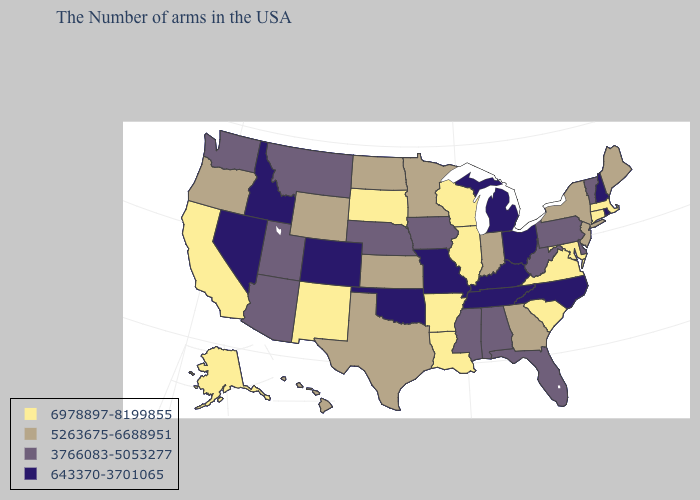Name the states that have a value in the range 643370-3701065?
Be succinct. Rhode Island, New Hampshire, North Carolina, Ohio, Michigan, Kentucky, Tennessee, Missouri, Oklahoma, Colorado, Idaho, Nevada. Name the states that have a value in the range 6978897-8199855?
Concise answer only. Massachusetts, Connecticut, Maryland, Virginia, South Carolina, Wisconsin, Illinois, Louisiana, Arkansas, South Dakota, New Mexico, California, Alaska. What is the value of Indiana?
Give a very brief answer. 5263675-6688951. Which states have the highest value in the USA?
Give a very brief answer. Massachusetts, Connecticut, Maryland, Virginia, South Carolina, Wisconsin, Illinois, Louisiana, Arkansas, South Dakota, New Mexico, California, Alaska. Name the states that have a value in the range 643370-3701065?
Give a very brief answer. Rhode Island, New Hampshire, North Carolina, Ohio, Michigan, Kentucky, Tennessee, Missouri, Oklahoma, Colorado, Idaho, Nevada. Does Nebraska have the highest value in the USA?
Quick response, please. No. What is the value of Nebraska?
Short answer required. 3766083-5053277. Among the states that border Delaware , does New Jersey have the highest value?
Keep it brief. No. What is the value of Kentucky?
Write a very short answer. 643370-3701065. Does Utah have a lower value than Massachusetts?
Keep it brief. Yes. What is the lowest value in states that border Vermont?
Give a very brief answer. 643370-3701065. What is the value of Arizona?
Answer briefly. 3766083-5053277. What is the highest value in the West ?
Write a very short answer. 6978897-8199855. What is the value of New Mexico?
Keep it brief. 6978897-8199855. Name the states that have a value in the range 643370-3701065?
Answer briefly. Rhode Island, New Hampshire, North Carolina, Ohio, Michigan, Kentucky, Tennessee, Missouri, Oklahoma, Colorado, Idaho, Nevada. 